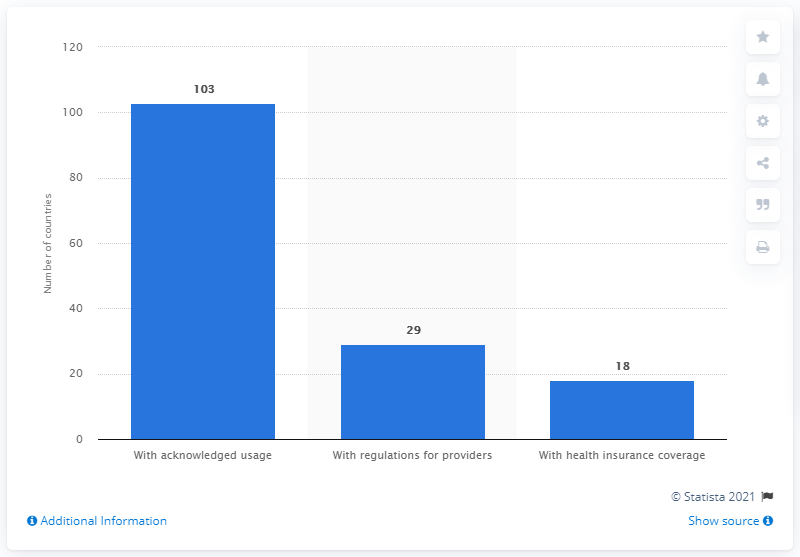Specify some key components in this picture. As of 2021, 29 World Health Organization (WHO) member states had regulations in place for providers of acupuncture services. 